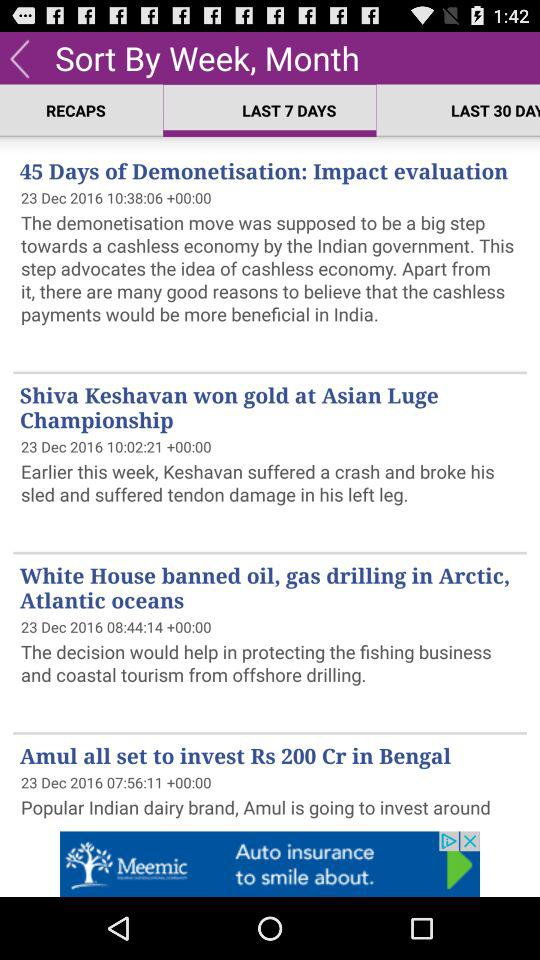How much money does "Amul" want to invest in Bengal? "Amul" wants to invest Rs. 200 crore in Bengal. 